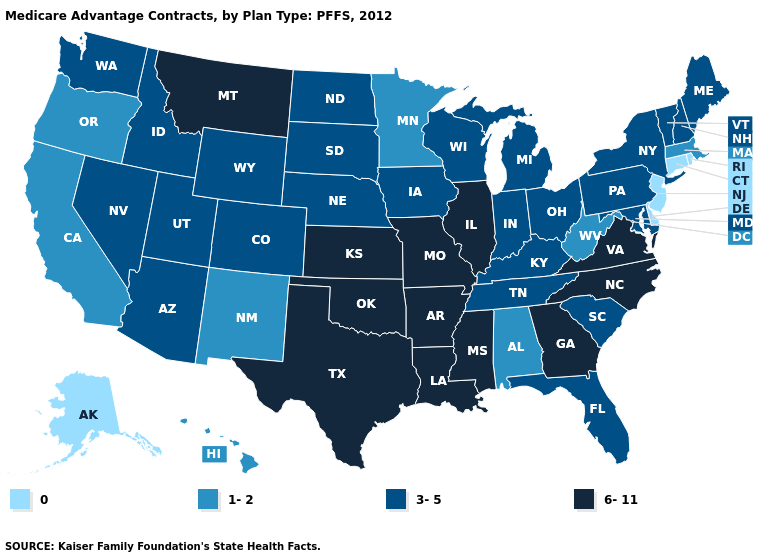Which states have the lowest value in the USA?
Concise answer only. Alaska, Connecticut, Delaware, New Jersey, Rhode Island. What is the value of Massachusetts?
Be succinct. 1-2. What is the value of Virginia?
Quick response, please. 6-11. Name the states that have a value in the range 0?
Be succinct. Alaska, Connecticut, Delaware, New Jersey, Rhode Island. What is the highest value in the USA?
Answer briefly. 6-11. Name the states that have a value in the range 0?
Keep it brief. Alaska, Connecticut, Delaware, New Jersey, Rhode Island. Does Louisiana have a higher value than Nebraska?
Quick response, please. Yes. Does Kansas have a lower value than Oregon?
Keep it brief. No. Name the states that have a value in the range 0?
Answer briefly. Alaska, Connecticut, Delaware, New Jersey, Rhode Island. Does the map have missing data?
Keep it brief. No. Does Mississippi have the highest value in the USA?
Quick response, please. Yes. Name the states that have a value in the range 3-5?
Short answer required. Arizona, Colorado, Florida, Iowa, Idaho, Indiana, Kentucky, Maryland, Maine, Michigan, North Dakota, Nebraska, New Hampshire, Nevada, New York, Ohio, Pennsylvania, South Carolina, South Dakota, Tennessee, Utah, Vermont, Washington, Wisconsin, Wyoming. What is the lowest value in the USA?
Be succinct. 0. Which states hav the highest value in the South?
Be succinct. Arkansas, Georgia, Louisiana, Mississippi, North Carolina, Oklahoma, Texas, Virginia. Name the states that have a value in the range 3-5?
Give a very brief answer. Arizona, Colorado, Florida, Iowa, Idaho, Indiana, Kentucky, Maryland, Maine, Michigan, North Dakota, Nebraska, New Hampshire, Nevada, New York, Ohio, Pennsylvania, South Carolina, South Dakota, Tennessee, Utah, Vermont, Washington, Wisconsin, Wyoming. 